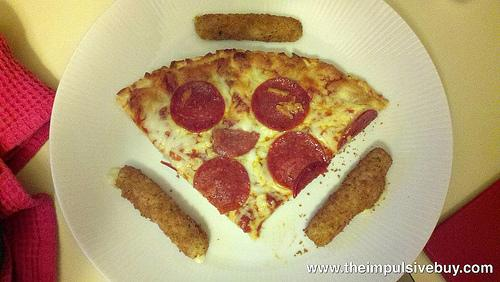Create a vivid description of the image, including the main elements and their attributes. A scrumptious pepperoni and cheese pizza slice sits invitingly on a white plate, accompanied by mouthwatering golden-brown mozzarella sticks oozing with cheese. Describe the main components in the image and emphasize their visual appearances. A visually delightful pizza slice with an abundance of pepperoni and gooey cheese, sharing a white plate with tempting mozzarella sticks that feature cheese spilling out from both ends. Mention the main items seen on the image, including their relative positions to each other. There's a pizza slice with pepperoni and cheese, mozzarella sticks nearby, and a web address at the corner. Write a brief overview of the prominent features in the image. There is a pizza slice with melted cheese and pepperoni, plus a couple of cheese sticks, all presented on a white plate. Provide a short and concise description of the main subject in the image. A large pepperoni and cheese pizza slice on a white plate with mozzarella sticks. Write an account of the image, focusing on the key elements and their arrangements. A tempting slice of pepperoni and cheese pizza sits at the center of a white plate, with scrumptious mozzarella sticks positioned nearby and a web address lurking in the corner. Describe the food items in the image, along with their main characteristics. A pepperoni and cheese pizza slice with melted cheese, and mozzarella sticks with cheese coming out both ends. List the main elements in the image, along with details about their appearances. Pepperoni and cheese pizza slice (with some buried under cheese), mozzarella sticks (one with cheese coming out both ends), and a web address at the bottom. Use sensory language to describe the main aspects of the image. A delectable pizza slice, covered in gooey cheese and spicy pepperoni, waits on a pristine white plate, while savory mozzarella sticks ooze warm cheese from their seams. Provide a narrative description of the main subject within the image. Upon a white plate lies a mouthwatering slice of pizza adorned with melted cheese and pepperoni, accompanied by soft and scrumptious cheese sticks craving to be devoured. 